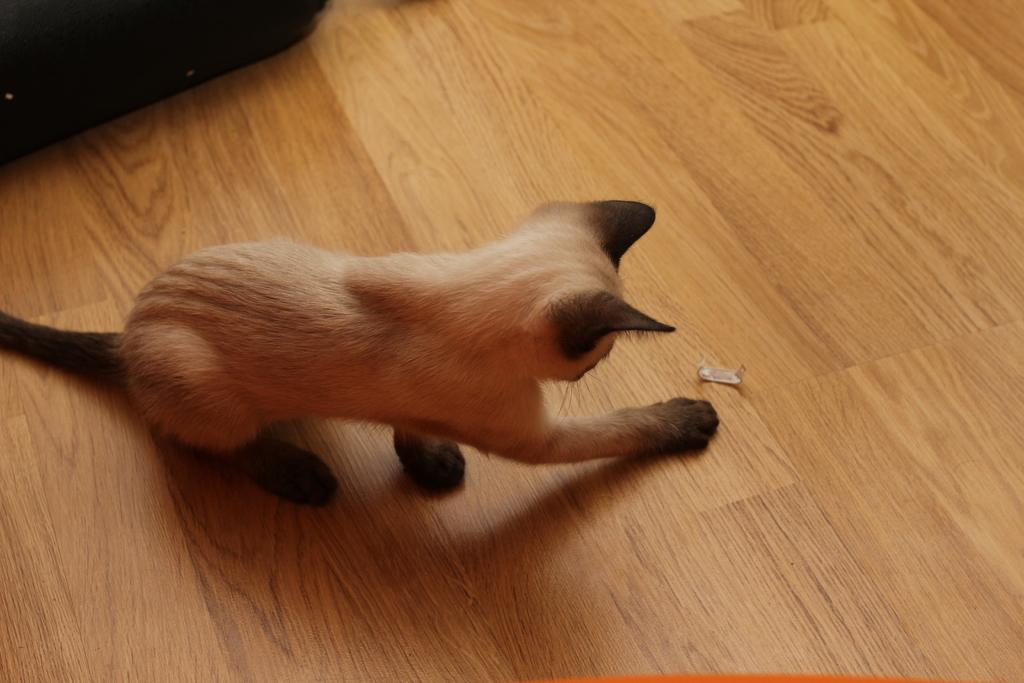What type of animal is in the image? There is a cat in the image. Where is the cat located in the image? The cat is sitting on the floor. What is in front of the cat? There is an object in front of the cat. What piece of furniture can be seen in the top left corner of the image? There is a sofa in the top left corner of the image. How does the cat's experience with expansion affect its behavior in the image? There is no information about the cat's experience with expansion in the image, so it cannot be determined how it affects the cat's behavior. 